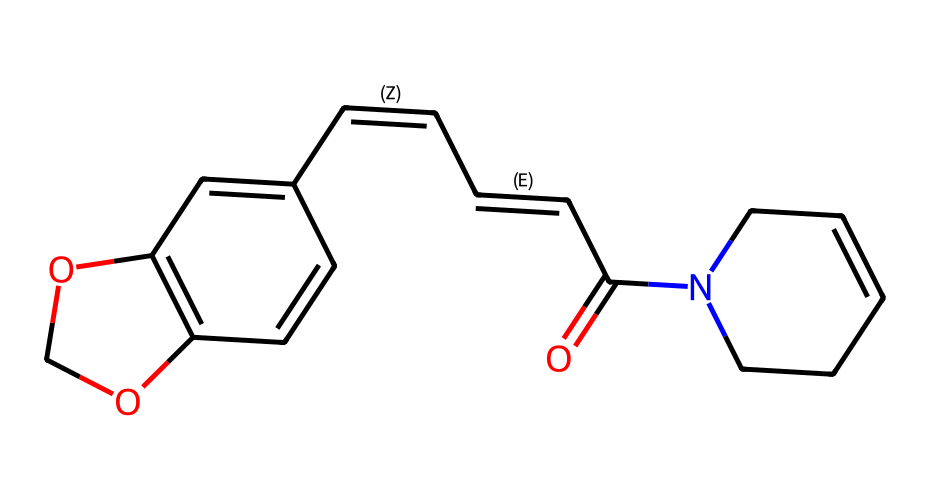How many rings are present in the structure of piperine? The chemical structure of piperine has two ring systems that can be identified by the presence of multiple aromatic or cyclic functionalities. Upon inspection, there are two distinct rings formed by the carbon atoms in the structure.
Answer: two What functional group is present in the piperine molecule? By looking at the chemical structure, we can identify a carbonyl group found in the molecule, specifically as indicated by the 'O=C' notation in the SMILES representation.
Answer: carbonyl What is the molecular formula for piperine? To determine the molecular formula, we can analyze the structure and count the number of each type of atom present in the molecule: carbon, hydrogen, oxygen, and nitrogen. The molecular formula comes out to C17H19NO3 after summing these elements.
Answer: C17H19NO3 Which type of compound is piperine classified as? Piperine is identified in the chemical structure by the presence of a nitrogen atom, which is typical for alkaloids. This classification can be explicitly deduced from its functional features and nitrogen content.
Answer: alkaloid What is the degree of unsaturation in the piperine structure? The degree of unsaturation can be calculated based on the number of rings and double bonds present. In this case, there are multiple double bonds (seen in the double bonds indicated in the structure) and two rings, leading to a value of 5 for the degree of unsaturation.
Answer: 5 What effect does the carbon-nitrogen bond have on piperine's properties? The carbon-nitrogen bond is characteristic of piperine and significantly influences its properties, primarily contributing to its pharmacological activities and making it a bioactive compound. This understanding is essential in grasping the functional aspects of its structure.
Answer: pharmacological activities What role does the hydroxyl group play in piperine? In the piperine structure, the hydroxyl group (-OH) contributes to the molecule's solubility and can influence its reactivity in chemical reactions due to the presence of oxygen and its polar nature. This can affect the way piperine interacts with other substances.
Answer: solubility and reactivity 